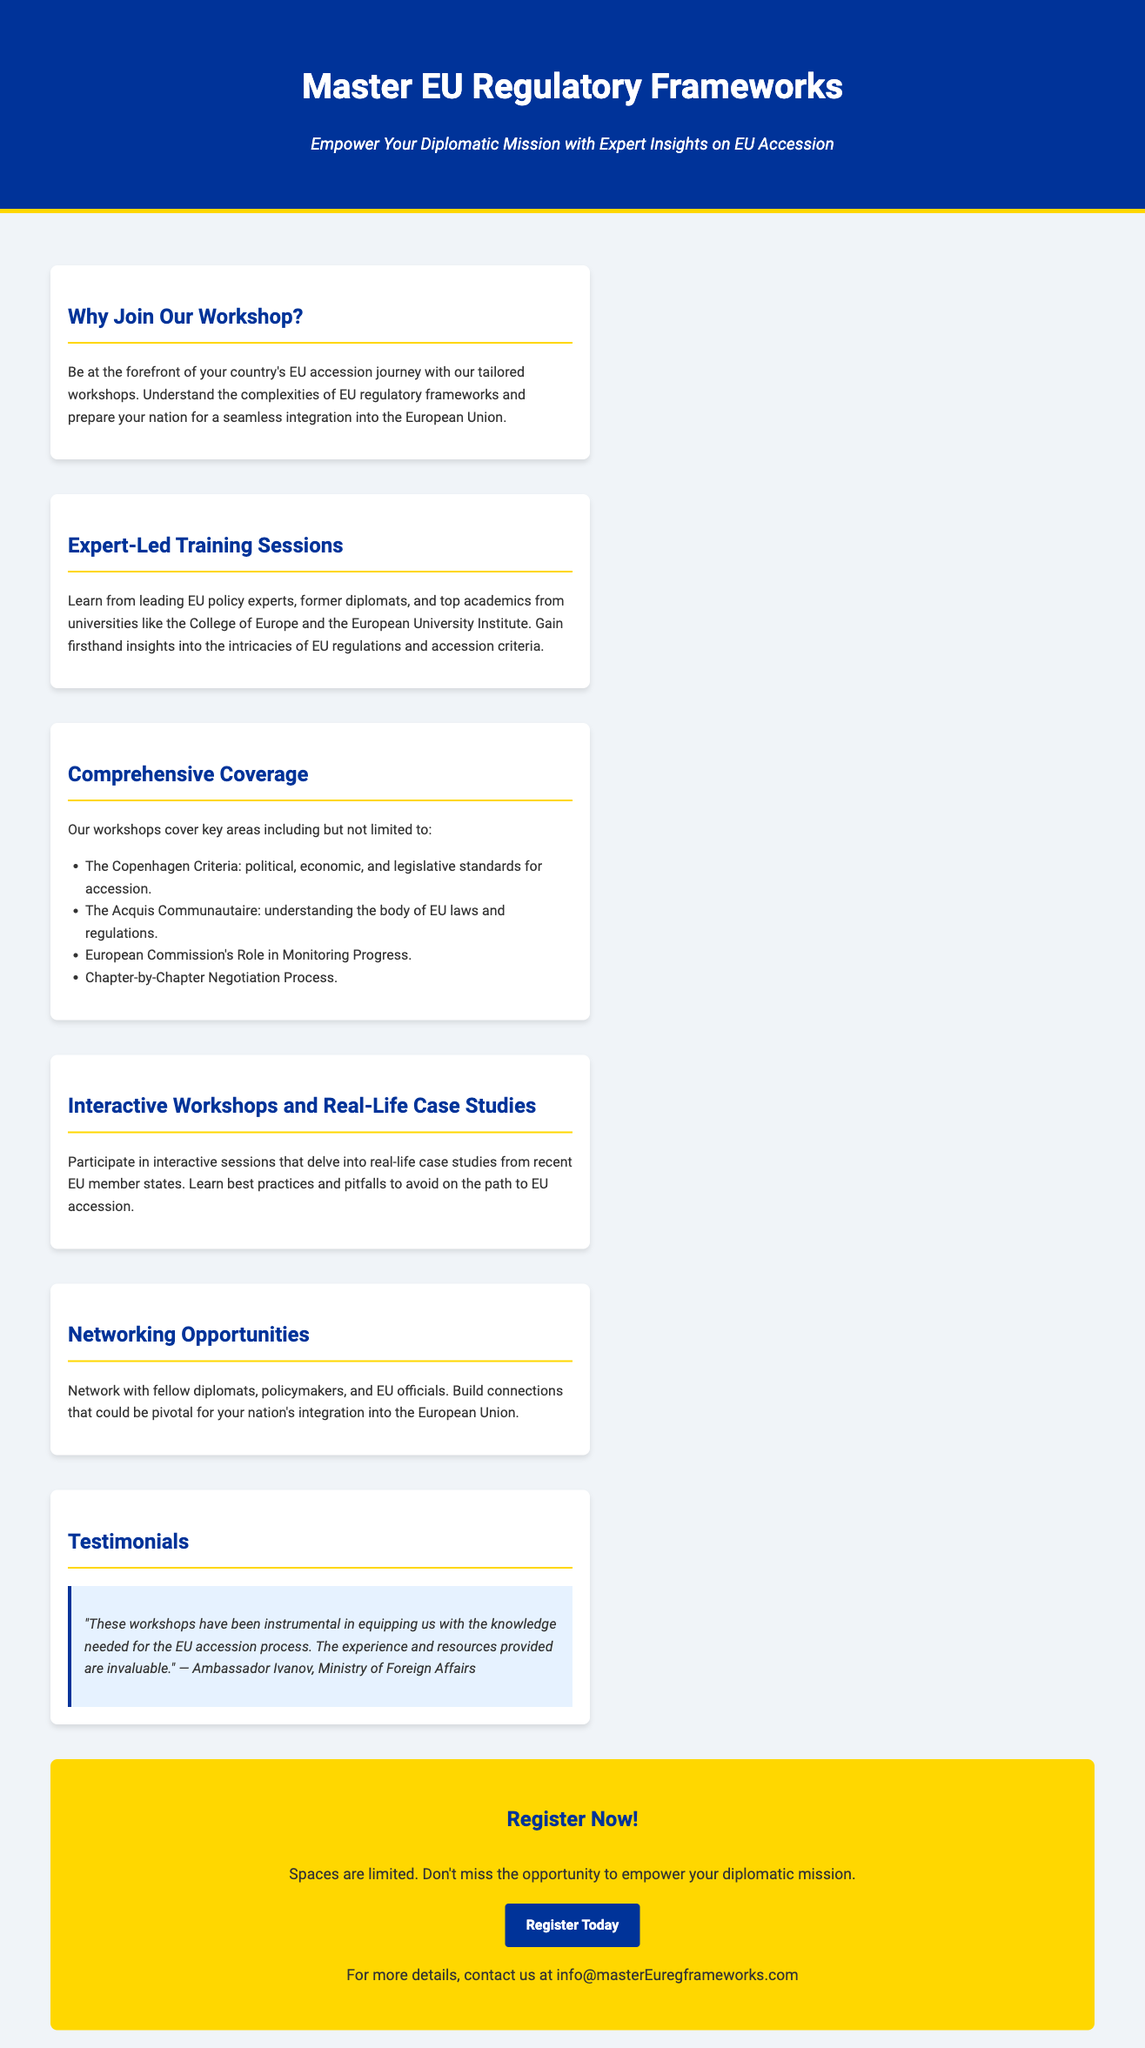What is the title of the workshop? The title of the workshop is stated prominently at the top of the document, emphasizing its main focus.
Answer: Master EU Regulatory Frameworks What is the tagline of the workshop? The tagline provides insight into the purpose of the workshop and is displayed just below the title.
Answer: Empower Your Diplomatic Mission with Expert Insights on EU Accession Who are the trainers for the sessions? The document mentions the types of trainers who will lead the sessions, highlighting their credentials and experience.
Answer: Leading EU policy experts, former diplomats, and top academics What key areas are covered in the workshops? The document lists specific areas included in the workshops, detailing the focus of the training.
Answer: The Copenhagen Criteria, The Acquis Communautaire, European Commission's Role, Chapter-by-Chapter Negotiation Process What type of learning method is emphasized in the workshops? The document describes the learning approach used in the workshops, indicating a hands-on experience with relevant applications.
Answer: Interactive Workshops and Real-Life Case Studies What is encouraged through the networking opportunities? The document outlines the benefit of networking during the event, emphasizing its importance for participants.
Answer: Build connections pivotal for integration into the EU What is the call to action at the end of the document? The final section of the document has a clear directive aimed at encouraging immediate engagement from readers.
Answer: Register Now! How can interested parties get more details? The document provides a specific contact method for those seeking further information about the workshop.
Answer: info@masterEuregframeworks.com 